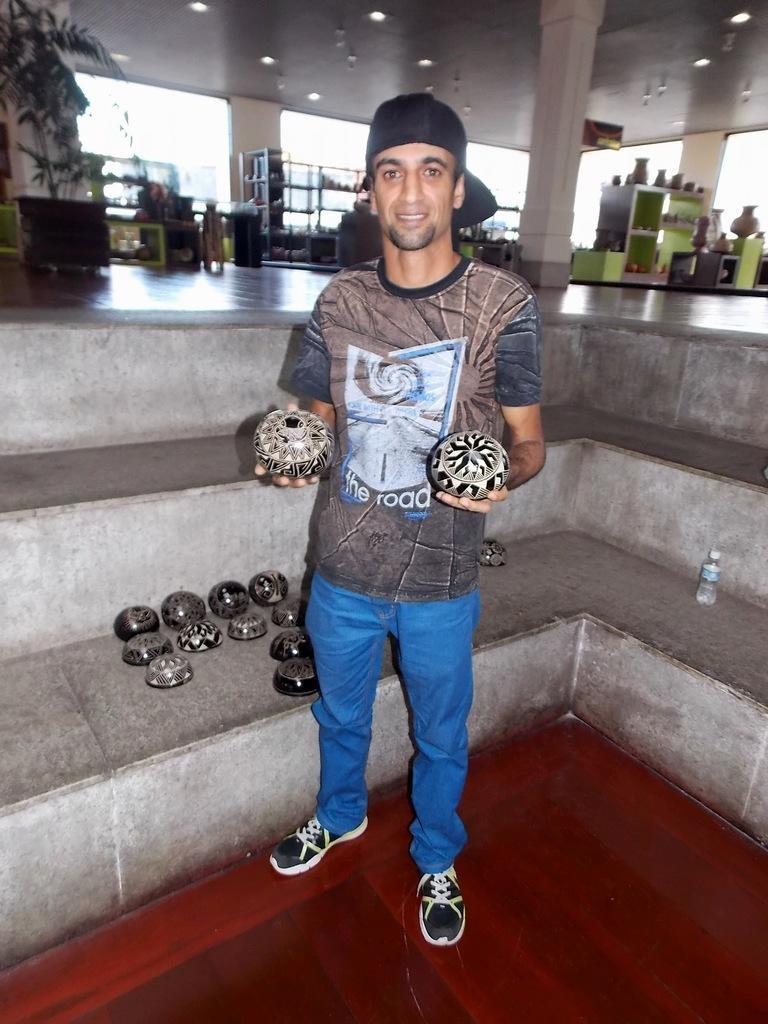In one or two sentences, can you explain what this image depicts? In this image in the middle there is a man, he wears a t shirt, trouser, shoes and cap, he is holding something. At the bottom there are stones and bottle. In the background there are cupboards, plant, lights, pillars and some other items. 